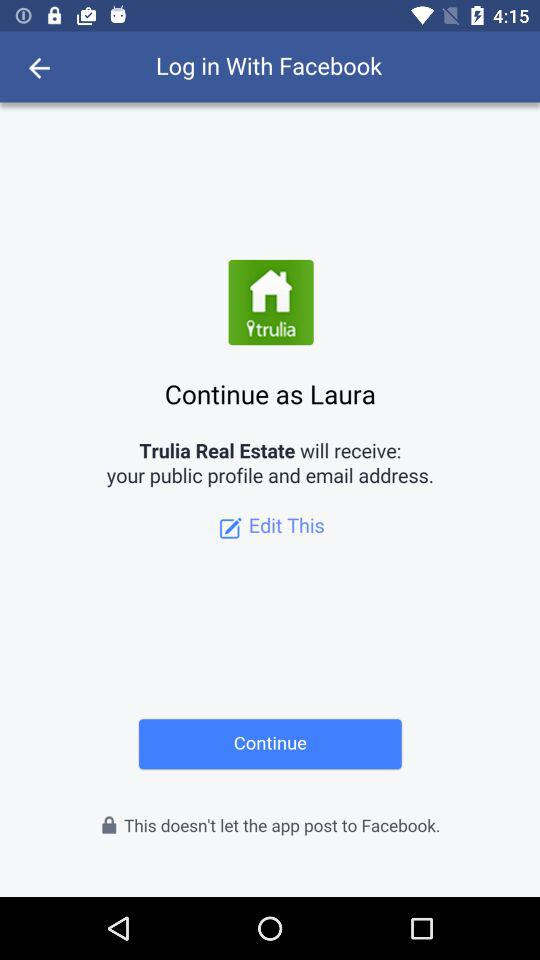What is the name of the user? The name of the user is Laura. 